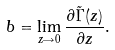<formula> <loc_0><loc_0><loc_500><loc_500>b = \lim _ { z \rightarrow 0 } \frac { \partial \tilde { \Gamma } ( z ) } { \partial z } .</formula> 